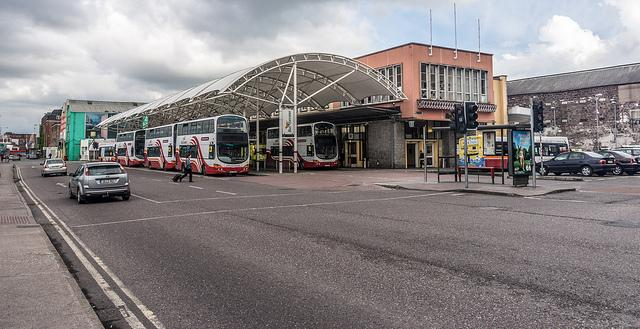What mass transit units sit parked here? Please explain your reasoning. busses. There are buses. 